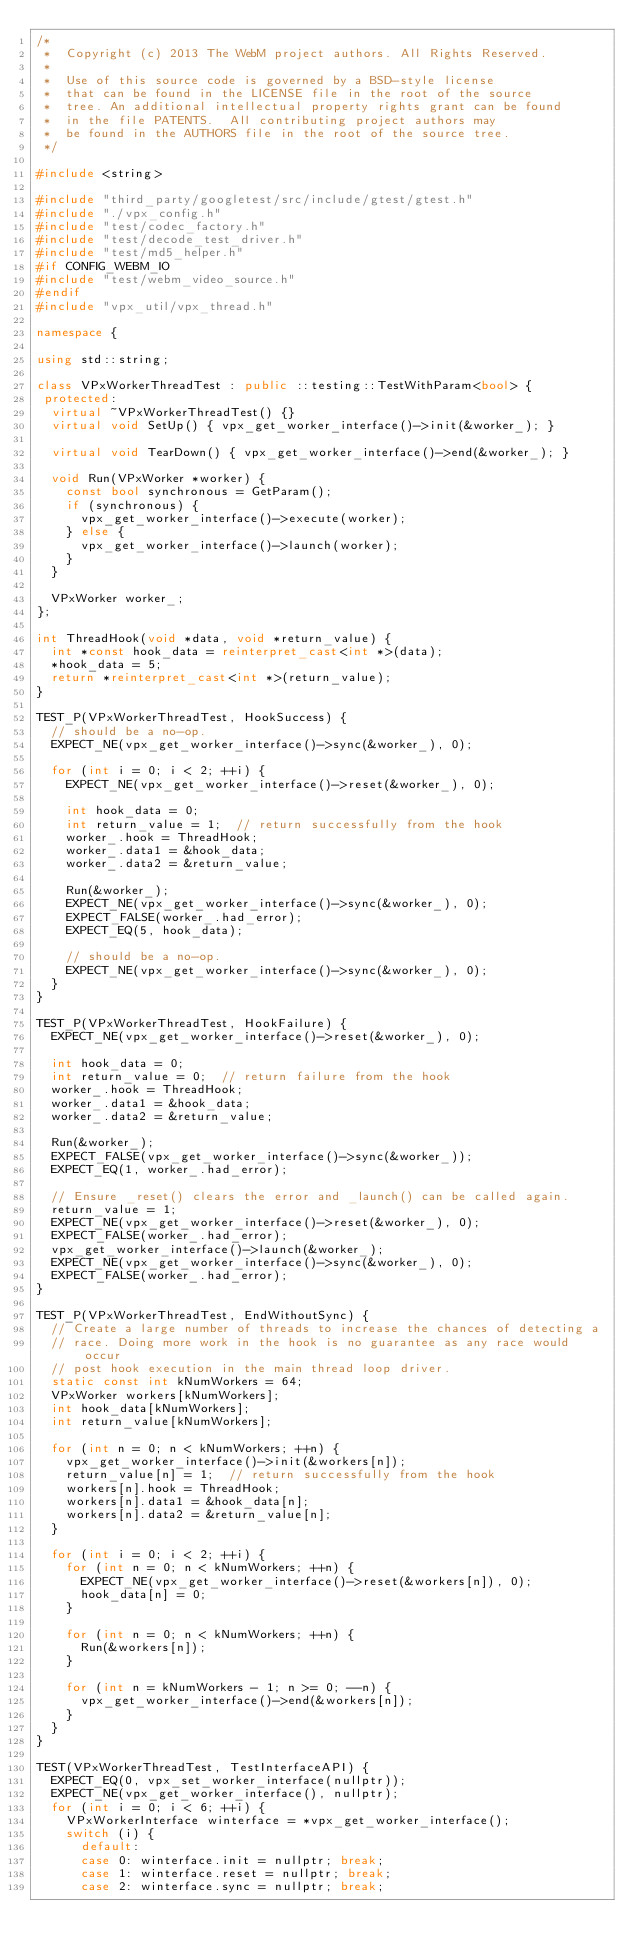<code> <loc_0><loc_0><loc_500><loc_500><_C++_>/*
 *  Copyright (c) 2013 The WebM project authors. All Rights Reserved.
 *
 *  Use of this source code is governed by a BSD-style license
 *  that can be found in the LICENSE file in the root of the source
 *  tree. An additional intellectual property rights grant can be found
 *  in the file PATENTS.  All contributing project authors may
 *  be found in the AUTHORS file in the root of the source tree.
 */

#include <string>

#include "third_party/googletest/src/include/gtest/gtest.h"
#include "./vpx_config.h"
#include "test/codec_factory.h"
#include "test/decode_test_driver.h"
#include "test/md5_helper.h"
#if CONFIG_WEBM_IO
#include "test/webm_video_source.h"
#endif
#include "vpx_util/vpx_thread.h"

namespace {

using std::string;

class VPxWorkerThreadTest : public ::testing::TestWithParam<bool> {
 protected:
  virtual ~VPxWorkerThreadTest() {}
  virtual void SetUp() { vpx_get_worker_interface()->init(&worker_); }

  virtual void TearDown() { vpx_get_worker_interface()->end(&worker_); }

  void Run(VPxWorker *worker) {
    const bool synchronous = GetParam();
    if (synchronous) {
      vpx_get_worker_interface()->execute(worker);
    } else {
      vpx_get_worker_interface()->launch(worker);
    }
  }

  VPxWorker worker_;
};

int ThreadHook(void *data, void *return_value) {
  int *const hook_data = reinterpret_cast<int *>(data);
  *hook_data = 5;
  return *reinterpret_cast<int *>(return_value);
}

TEST_P(VPxWorkerThreadTest, HookSuccess) {
  // should be a no-op.
  EXPECT_NE(vpx_get_worker_interface()->sync(&worker_), 0);

  for (int i = 0; i < 2; ++i) {
    EXPECT_NE(vpx_get_worker_interface()->reset(&worker_), 0);

    int hook_data = 0;
    int return_value = 1;  // return successfully from the hook
    worker_.hook = ThreadHook;
    worker_.data1 = &hook_data;
    worker_.data2 = &return_value;

    Run(&worker_);
    EXPECT_NE(vpx_get_worker_interface()->sync(&worker_), 0);
    EXPECT_FALSE(worker_.had_error);
    EXPECT_EQ(5, hook_data);

    // should be a no-op.
    EXPECT_NE(vpx_get_worker_interface()->sync(&worker_), 0);
  }
}

TEST_P(VPxWorkerThreadTest, HookFailure) {
  EXPECT_NE(vpx_get_worker_interface()->reset(&worker_), 0);

  int hook_data = 0;
  int return_value = 0;  // return failure from the hook
  worker_.hook = ThreadHook;
  worker_.data1 = &hook_data;
  worker_.data2 = &return_value;

  Run(&worker_);
  EXPECT_FALSE(vpx_get_worker_interface()->sync(&worker_));
  EXPECT_EQ(1, worker_.had_error);

  // Ensure _reset() clears the error and _launch() can be called again.
  return_value = 1;
  EXPECT_NE(vpx_get_worker_interface()->reset(&worker_), 0);
  EXPECT_FALSE(worker_.had_error);
  vpx_get_worker_interface()->launch(&worker_);
  EXPECT_NE(vpx_get_worker_interface()->sync(&worker_), 0);
  EXPECT_FALSE(worker_.had_error);
}

TEST_P(VPxWorkerThreadTest, EndWithoutSync) {
  // Create a large number of threads to increase the chances of detecting a
  // race. Doing more work in the hook is no guarantee as any race would occur
  // post hook execution in the main thread loop driver.
  static const int kNumWorkers = 64;
  VPxWorker workers[kNumWorkers];
  int hook_data[kNumWorkers];
  int return_value[kNumWorkers];

  for (int n = 0; n < kNumWorkers; ++n) {
    vpx_get_worker_interface()->init(&workers[n]);
    return_value[n] = 1;  // return successfully from the hook
    workers[n].hook = ThreadHook;
    workers[n].data1 = &hook_data[n];
    workers[n].data2 = &return_value[n];
  }

  for (int i = 0; i < 2; ++i) {
    for (int n = 0; n < kNumWorkers; ++n) {
      EXPECT_NE(vpx_get_worker_interface()->reset(&workers[n]), 0);
      hook_data[n] = 0;
    }

    for (int n = 0; n < kNumWorkers; ++n) {
      Run(&workers[n]);
    }

    for (int n = kNumWorkers - 1; n >= 0; --n) {
      vpx_get_worker_interface()->end(&workers[n]);
    }
  }
}

TEST(VPxWorkerThreadTest, TestInterfaceAPI) {
  EXPECT_EQ(0, vpx_set_worker_interface(nullptr));
  EXPECT_NE(vpx_get_worker_interface(), nullptr);
  for (int i = 0; i < 6; ++i) {
    VPxWorkerInterface winterface = *vpx_get_worker_interface();
    switch (i) {
      default:
      case 0: winterface.init = nullptr; break;
      case 1: winterface.reset = nullptr; break;
      case 2: winterface.sync = nullptr; break;</code> 